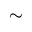<formula> <loc_0><loc_0><loc_500><loc_500>\sim</formula> 